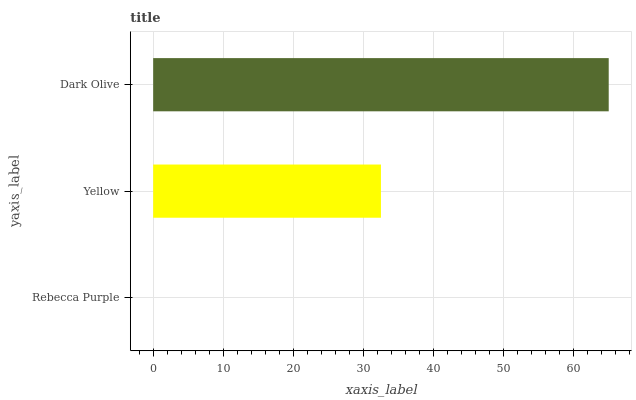Is Rebecca Purple the minimum?
Answer yes or no. Yes. Is Dark Olive the maximum?
Answer yes or no. Yes. Is Yellow the minimum?
Answer yes or no. No. Is Yellow the maximum?
Answer yes or no. No. Is Yellow greater than Rebecca Purple?
Answer yes or no. Yes. Is Rebecca Purple less than Yellow?
Answer yes or no. Yes. Is Rebecca Purple greater than Yellow?
Answer yes or no. No. Is Yellow less than Rebecca Purple?
Answer yes or no. No. Is Yellow the high median?
Answer yes or no. Yes. Is Yellow the low median?
Answer yes or no. Yes. Is Rebecca Purple the high median?
Answer yes or no. No. Is Dark Olive the low median?
Answer yes or no. No. 